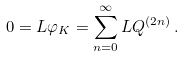<formula> <loc_0><loc_0><loc_500><loc_500>0 = L \varphi _ { K } = \sum _ { n = 0 } ^ { \infty } L Q ^ { ( 2 n ) } \, .</formula> 